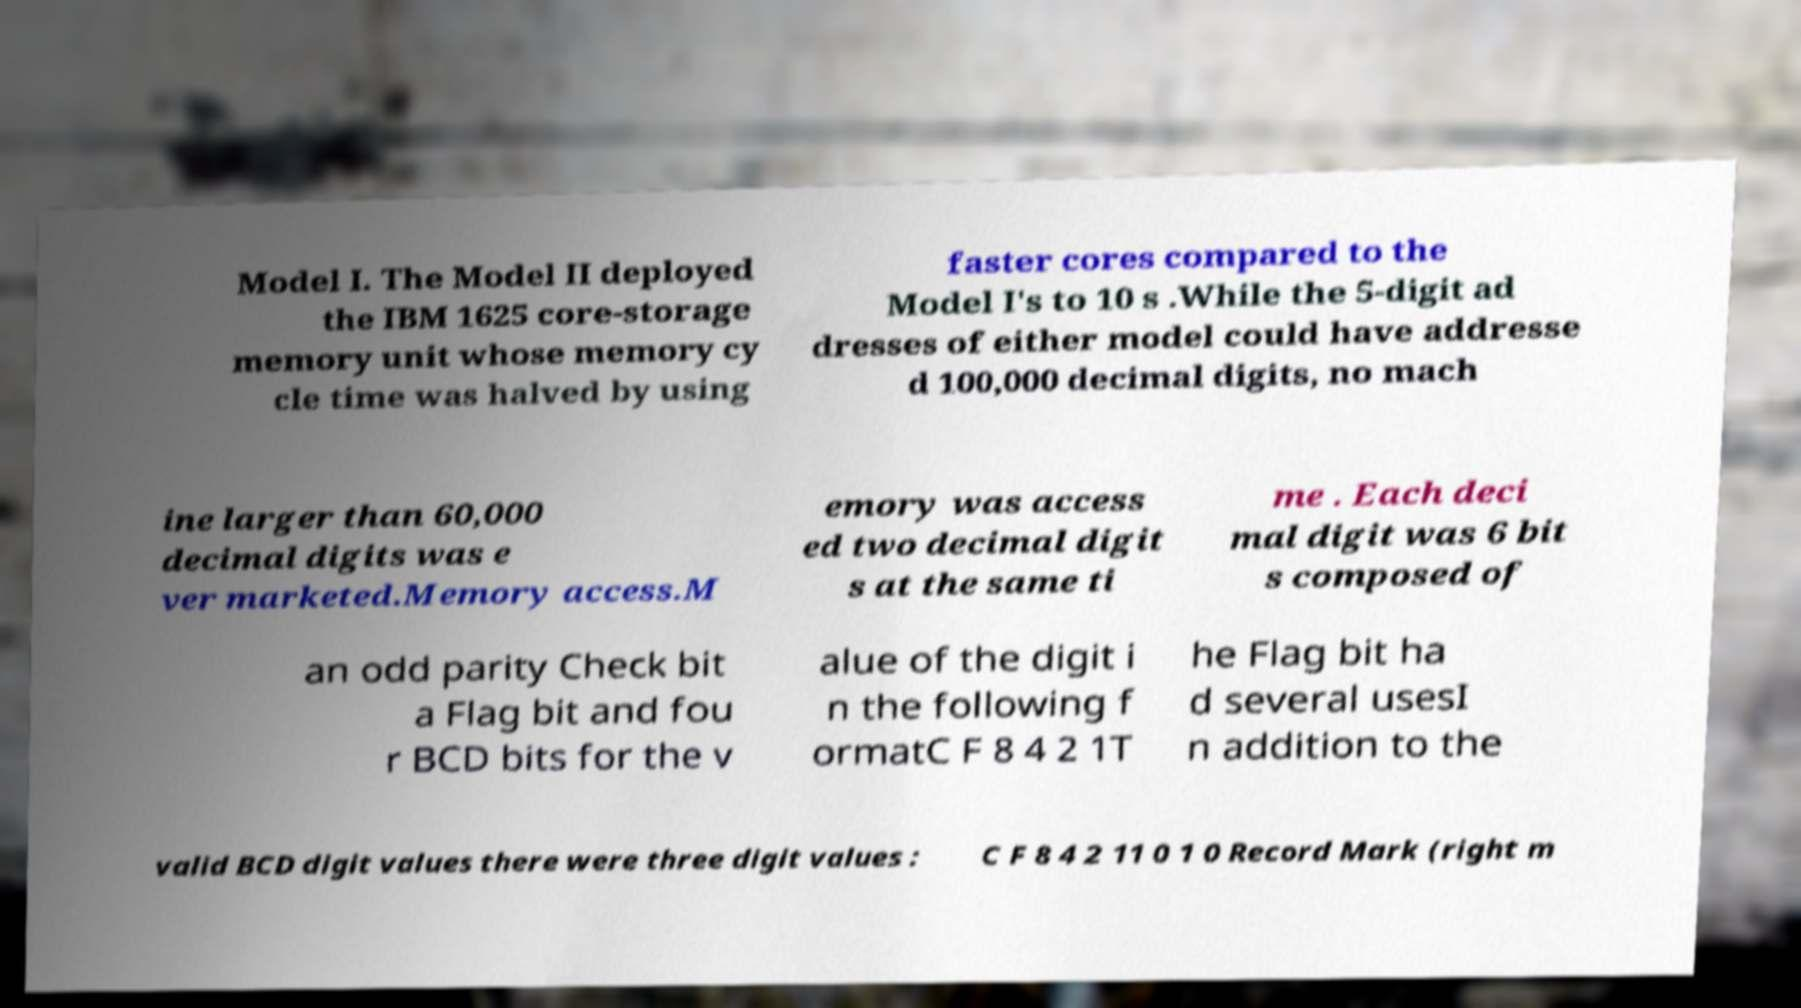Can you accurately transcribe the text from the provided image for me? Model I. The Model II deployed the IBM 1625 core-storage memory unit whose memory cy cle time was halved by using faster cores compared to the Model I's to 10 s .While the 5-digit ad dresses of either model could have addresse d 100,000 decimal digits, no mach ine larger than 60,000 decimal digits was e ver marketed.Memory access.M emory was access ed two decimal digit s at the same ti me . Each deci mal digit was 6 bit s composed of an odd parity Check bit a Flag bit and fou r BCD bits for the v alue of the digit i n the following f ormatC F 8 4 2 1T he Flag bit ha d several usesI n addition to the valid BCD digit values there were three digit values : C F 8 4 2 11 0 1 0 Record Mark (right m 